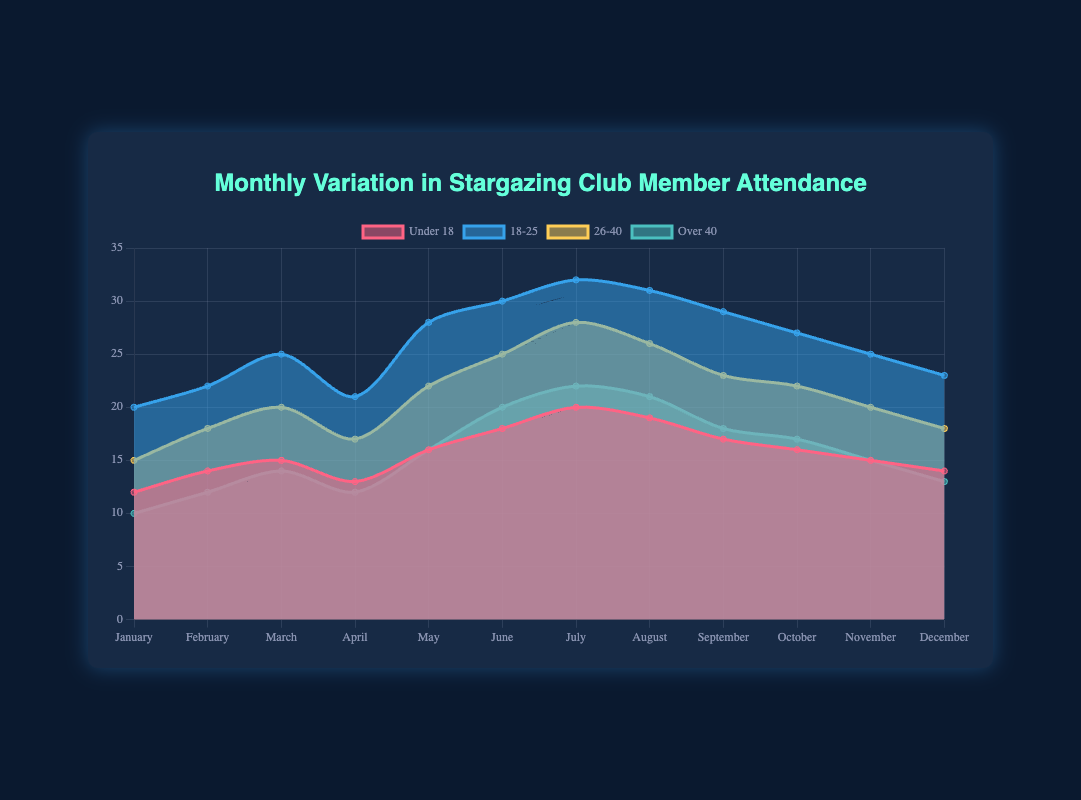What months have the highest attendance in the 'Under 18' group? To determine the highest attendance months for the 'Under 18' group, look at the peak points in the 'Under 18' dataset trace over the months. The highest values in the 'Under 18' group occur in July (20) and June (18).
Answer: July and June Which age group has the most stable attendance throughout the year? To identify the most stable attendance, check which age group's area does not fluctuate much. The 'Over 40' group has the least fluctuations, ranging only from 10 to 22, indicating greater stability compared to other age groups.
Answer: Over 40 What is the combined attendance for all age groups in March? Sum the values for all age groups in March: Under 18 (15) + 18-25 (25) + 26-40 (20) + Over 40 (14). The total is 15 + 25 + 20 + 14, amounting to 74.
Answer: 74 In which month is the attendance for the '26-40' age group the highest, and what is the value? Look at the '26-40' dataset trace and find the peak. The highest attendance for the '26-40' group is in July with a value of 28.
Answer: July, 28 Which group shows the most noticeable increase in attendance from January to June? Calculate the difference between June and January for each group. For 'Under 18', the increase is 6 (18-12), for '18-25', it's 10 (30-20), for '26-40', it's 10 (25-15), and for 'Over 40', it's 10 (20-10). The '18-25', '26-40' and 'Over 40' groups show the most noticeable increase, each with an increase of 10.
Answer: 18-25, 26-40, Over 40 How does attendance for the '18-25' group in February compare to that of the 'Over 40' group in the same month? Compare the February values for '18-25' (22) and 'Over 40' (12). The '18-25' group has 10 more attendees than the 'Over 40' group.
Answer: Higher by 10 What's the trend in attendance for the 'Under 18' group from May to August? Observe the 'Under 18' group values from May (16) to August (19). The values show an increasing trend from May to July (16 → 18 → 20) and a slight decrease in August (19).
Answer: Increasing trend with a slight decline in August During which month does the attendance for all age groups combined peak? Add the attendance values for all age groups month by month and find the peak month. The combined attendance peaks in July: 20 (Under 18) + 32 (18-25) + 28 (26-40) + 22 (Over 40) = 102.
Answer: July How does the '18-25' group's attendance change from October to December? Observe the values for '18-25' from October (27), November (25), to December (23). The attendance decreases consistently each month: 27 → 25 → 23.
Answer: Decreases 